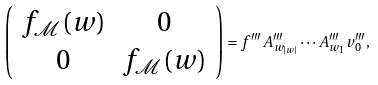<formula> <loc_0><loc_0><loc_500><loc_500>\left ( \begin{array} { c c } f _ { \mathcal { M } } ( w ) & 0 \\ 0 & f _ { \mathcal { M } } ( w ) \end{array} \right ) = f ^ { \prime \prime \prime } A ^ { \prime \prime \prime } _ { w _ { | w | } } \cdots A ^ { \prime \prime \prime } _ { w _ { 1 } } v _ { 0 } ^ { \prime \prime \prime } ,</formula> 